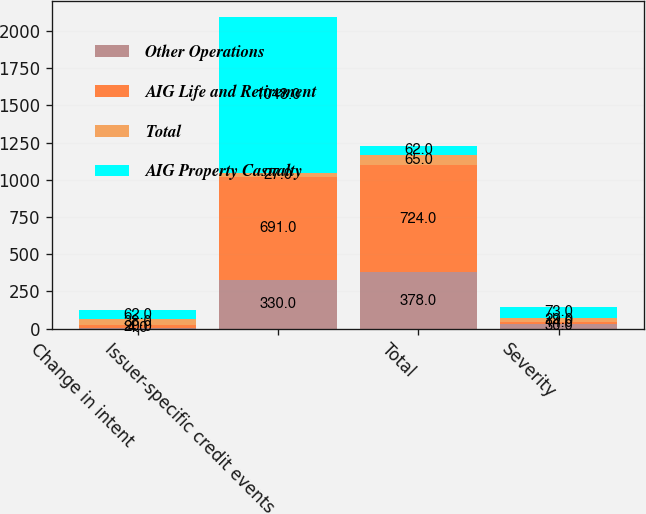Convert chart. <chart><loc_0><loc_0><loc_500><loc_500><stacked_bar_chart><ecel><fcel>Change in intent<fcel>Issuer-specific credit events<fcel>Total<fcel>Severity<nl><fcel>Other Operations<fcel>4<fcel>330<fcel>378<fcel>30<nl><fcel>AIG Life and Retirement<fcel>20<fcel>691<fcel>724<fcel>14<nl><fcel>Total<fcel>38<fcel>27<fcel>65<fcel>29<nl><fcel>AIG Property Casualty<fcel>62<fcel>1048<fcel>62<fcel>73<nl></chart> 